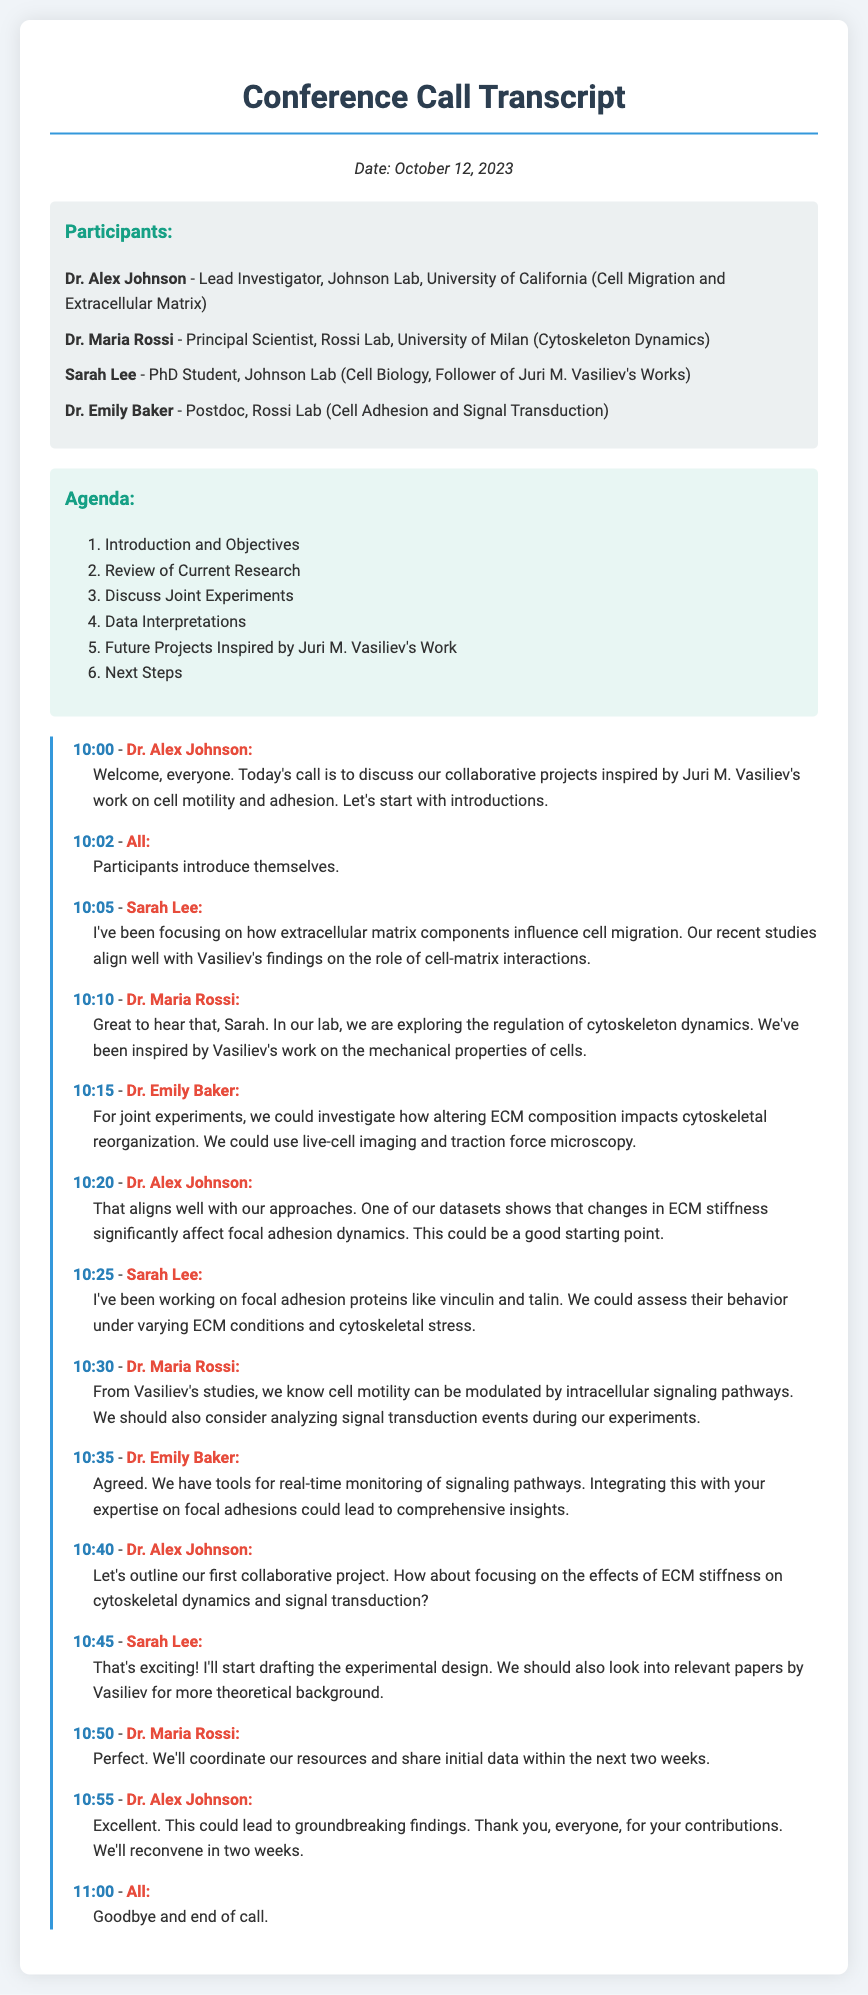What is the date of the conference call? The date is specified at the beginning of the document as October 12, 2023.
Answer: October 12, 2023 Who is the lead investigator of the Johnson Lab? The participant list identifies Dr. Alex Johnson as the Lead Investigator of the Johnson Lab.
Answer: Dr. Alex Johnson Which laboratory does Dr. Maria Rossi represent? The document states that Dr. Maria Rossi is from the Rossi Lab at the University of Milan.
Answer: Rossi Lab, University of Milan How many main agenda items are listed? The agenda section of the document lists six main items for discussion.
Answer: 6 What topic does Sarah Lee focus on in her research? Sarah Lee mentions her focus on how extracellular matrix components influence cell migration.
Answer: Extracellular matrix components influence cell migration Which tools did Dr. Emily Baker reference for monitoring? Dr. Emily Baker refers to tools for real-time monitoring of signaling pathways.
Answer: Real-time monitoring of signaling pathways What is the first collaborative project discussed? The first collaborative project outlined focuses on the effects of ECM stiffness on cytoskeletal dynamics and signal transduction.
Answer: Effects of ECM stiffness on cytoskeletal dynamics and signal transduction How soon will the participants reconvene? Dr. Alex Johnson mentions that they will reconvene in two weeks.
Answer: Two weeks 